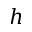Convert formula to latex. <formula><loc_0><loc_0><loc_500><loc_500>h</formula> 